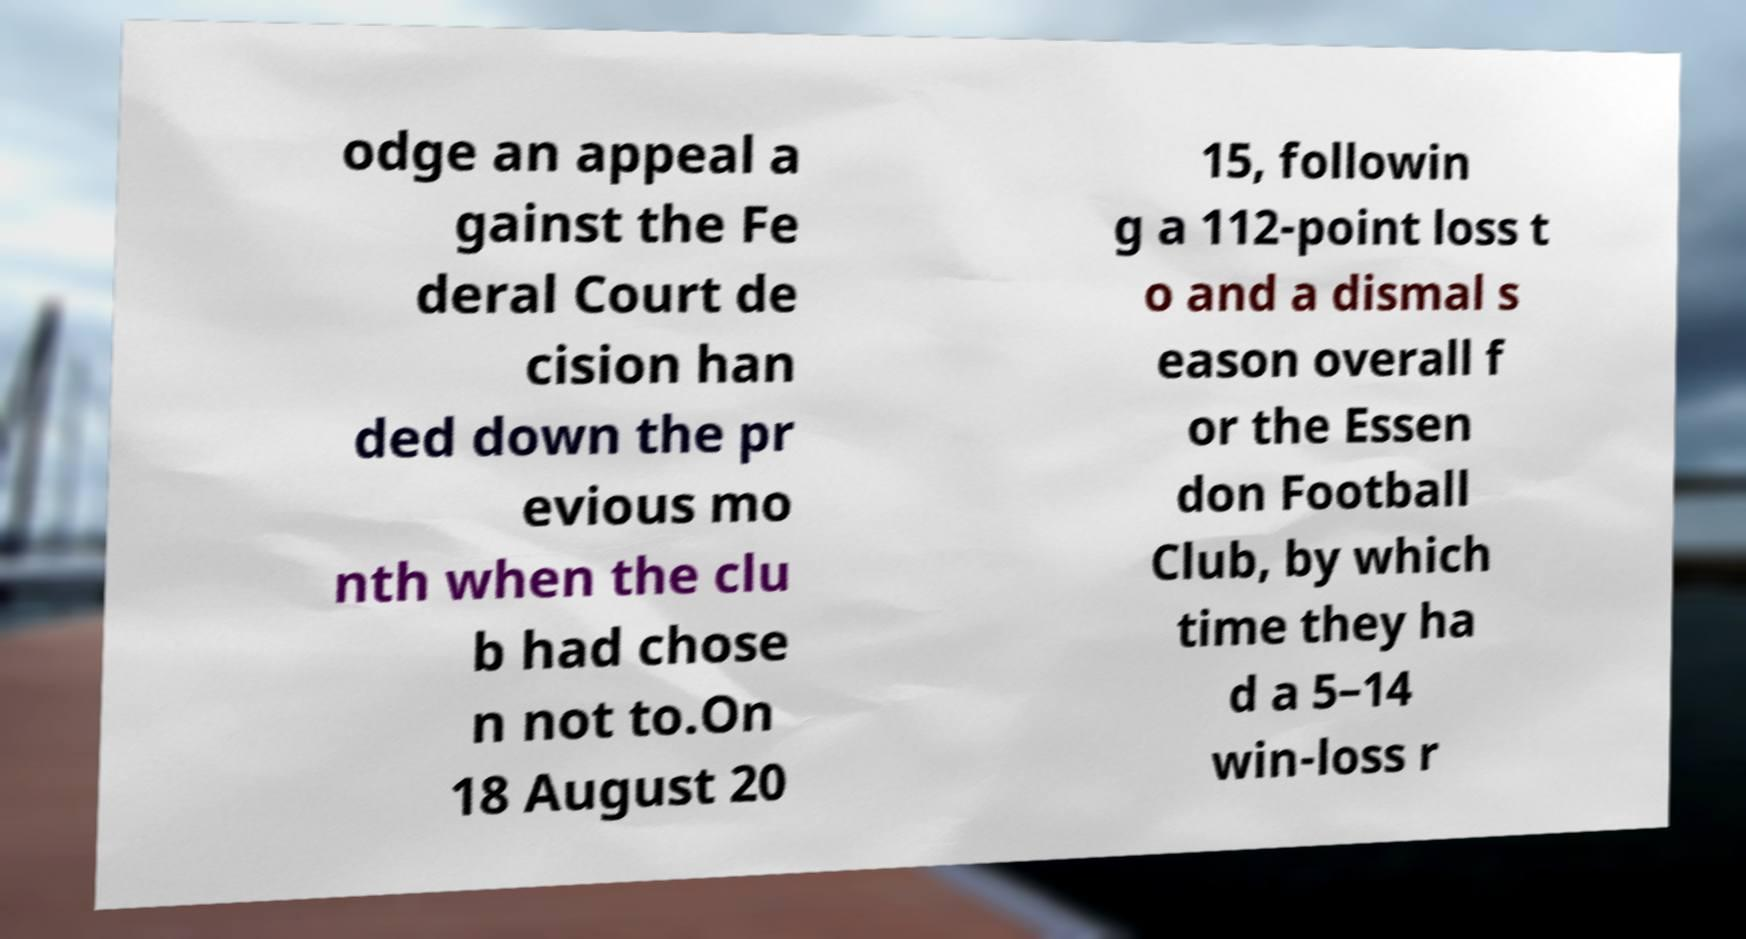For documentation purposes, I need the text within this image transcribed. Could you provide that? odge an appeal a gainst the Fe deral Court de cision han ded down the pr evious mo nth when the clu b had chose n not to.On 18 August 20 15, followin g a 112-point loss t o and a dismal s eason overall f or the Essen don Football Club, by which time they ha d a 5–14 win-loss r 